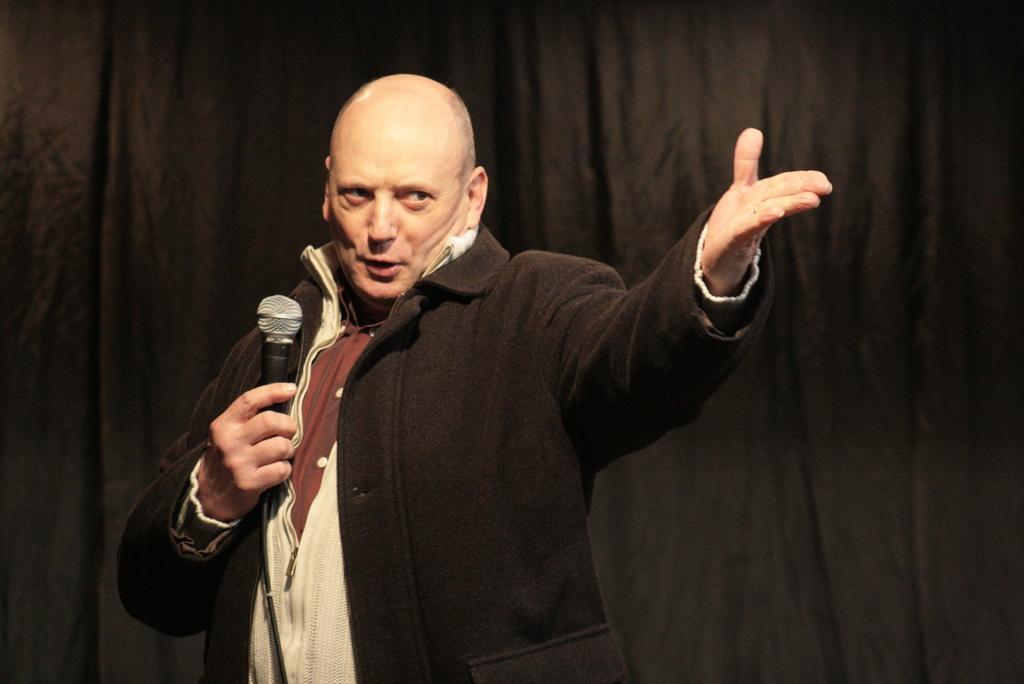Please provide a concise description of this image. A man is speaking with a mic in his hand. He is showing his hand towards audience. There is a black screen behind him. 